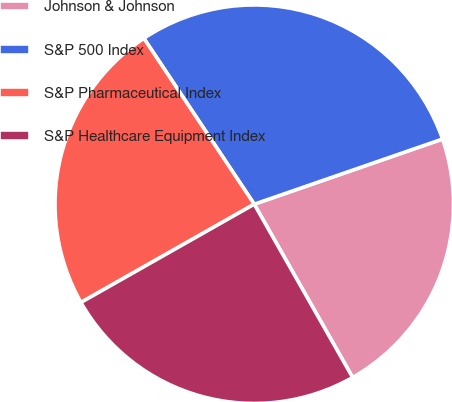Convert chart to OTSL. <chart><loc_0><loc_0><loc_500><loc_500><pie_chart><fcel>Johnson & Johnson<fcel>S&P 500 Index<fcel>S&P Pharmaceutical Index<fcel>S&P Healthcare Equipment Index<nl><fcel>22.08%<fcel>29.04%<fcel>23.86%<fcel>25.01%<nl></chart> 